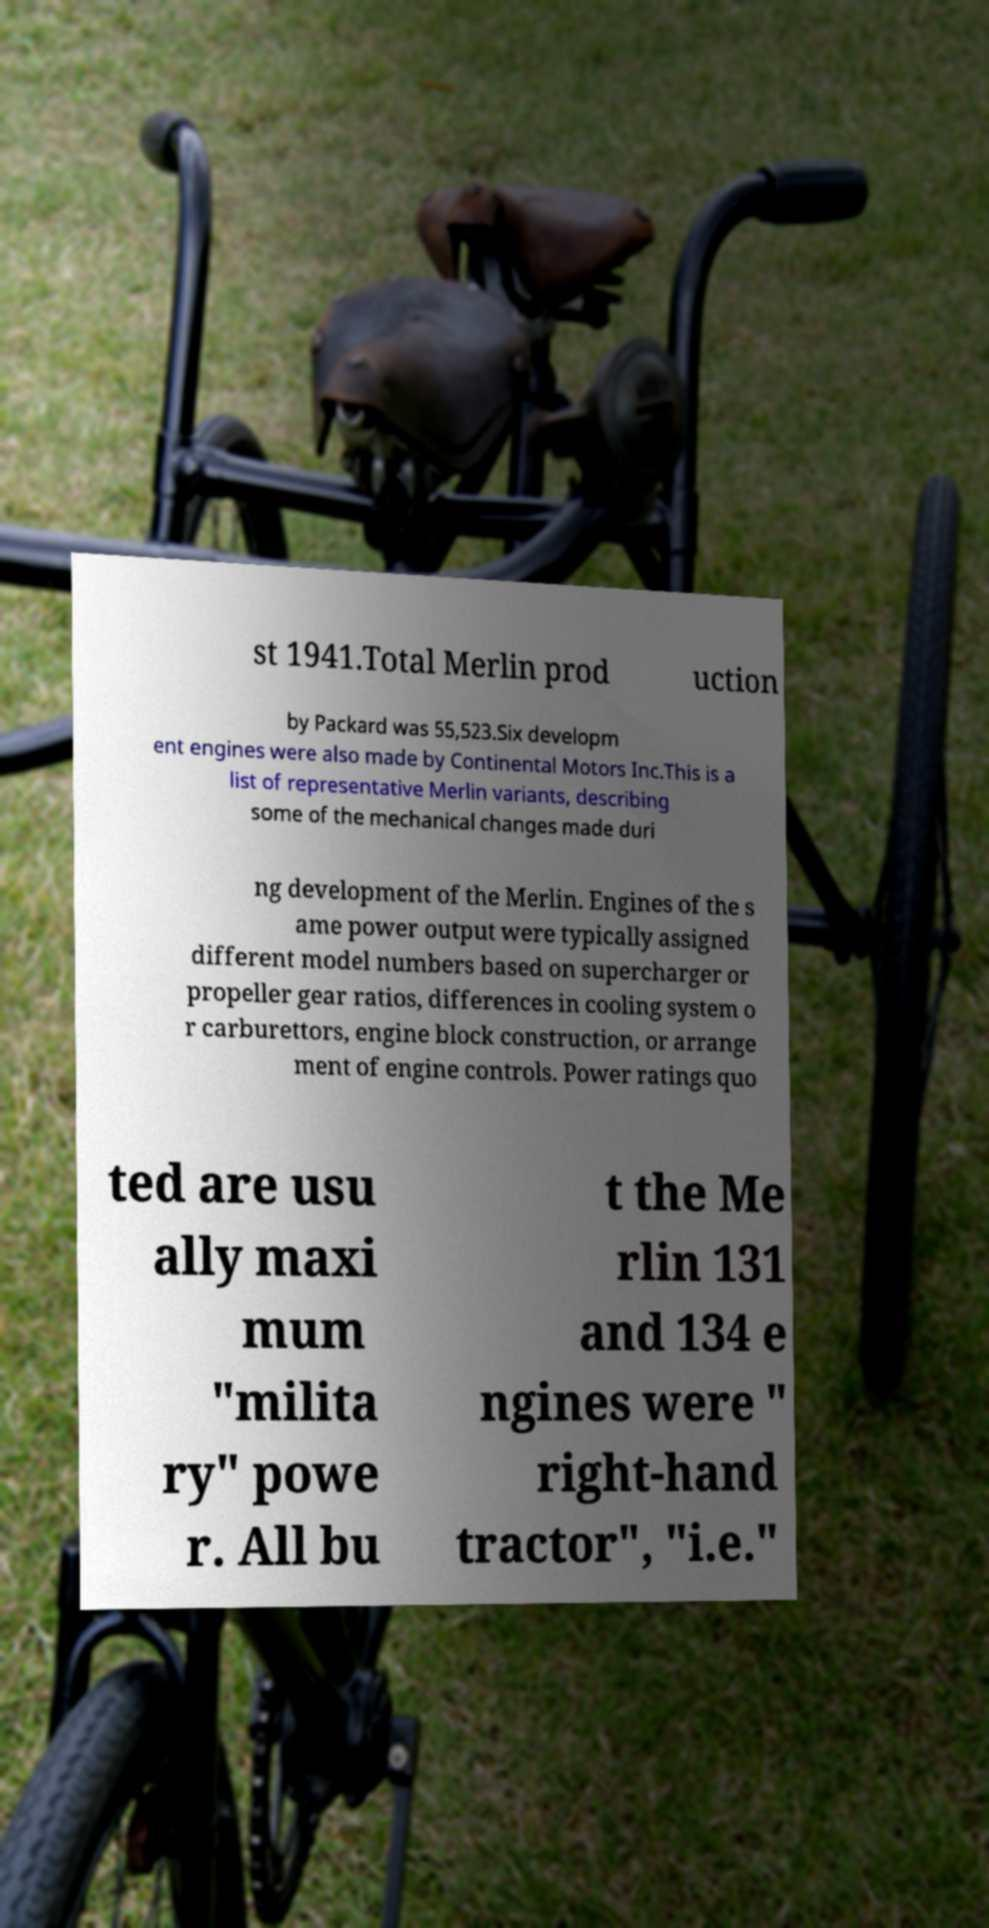For documentation purposes, I need the text within this image transcribed. Could you provide that? st 1941.Total Merlin prod uction by Packard was 55,523.Six developm ent engines were also made by Continental Motors Inc.This is a list of representative Merlin variants, describing some of the mechanical changes made duri ng development of the Merlin. Engines of the s ame power output were typically assigned different model numbers based on supercharger or propeller gear ratios, differences in cooling system o r carburettors, engine block construction, or arrange ment of engine controls. Power ratings quo ted are usu ally maxi mum "milita ry" powe r. All bu t the Me rlin 131 and 134 e ngines were " right-hand tractor", "i.e." 